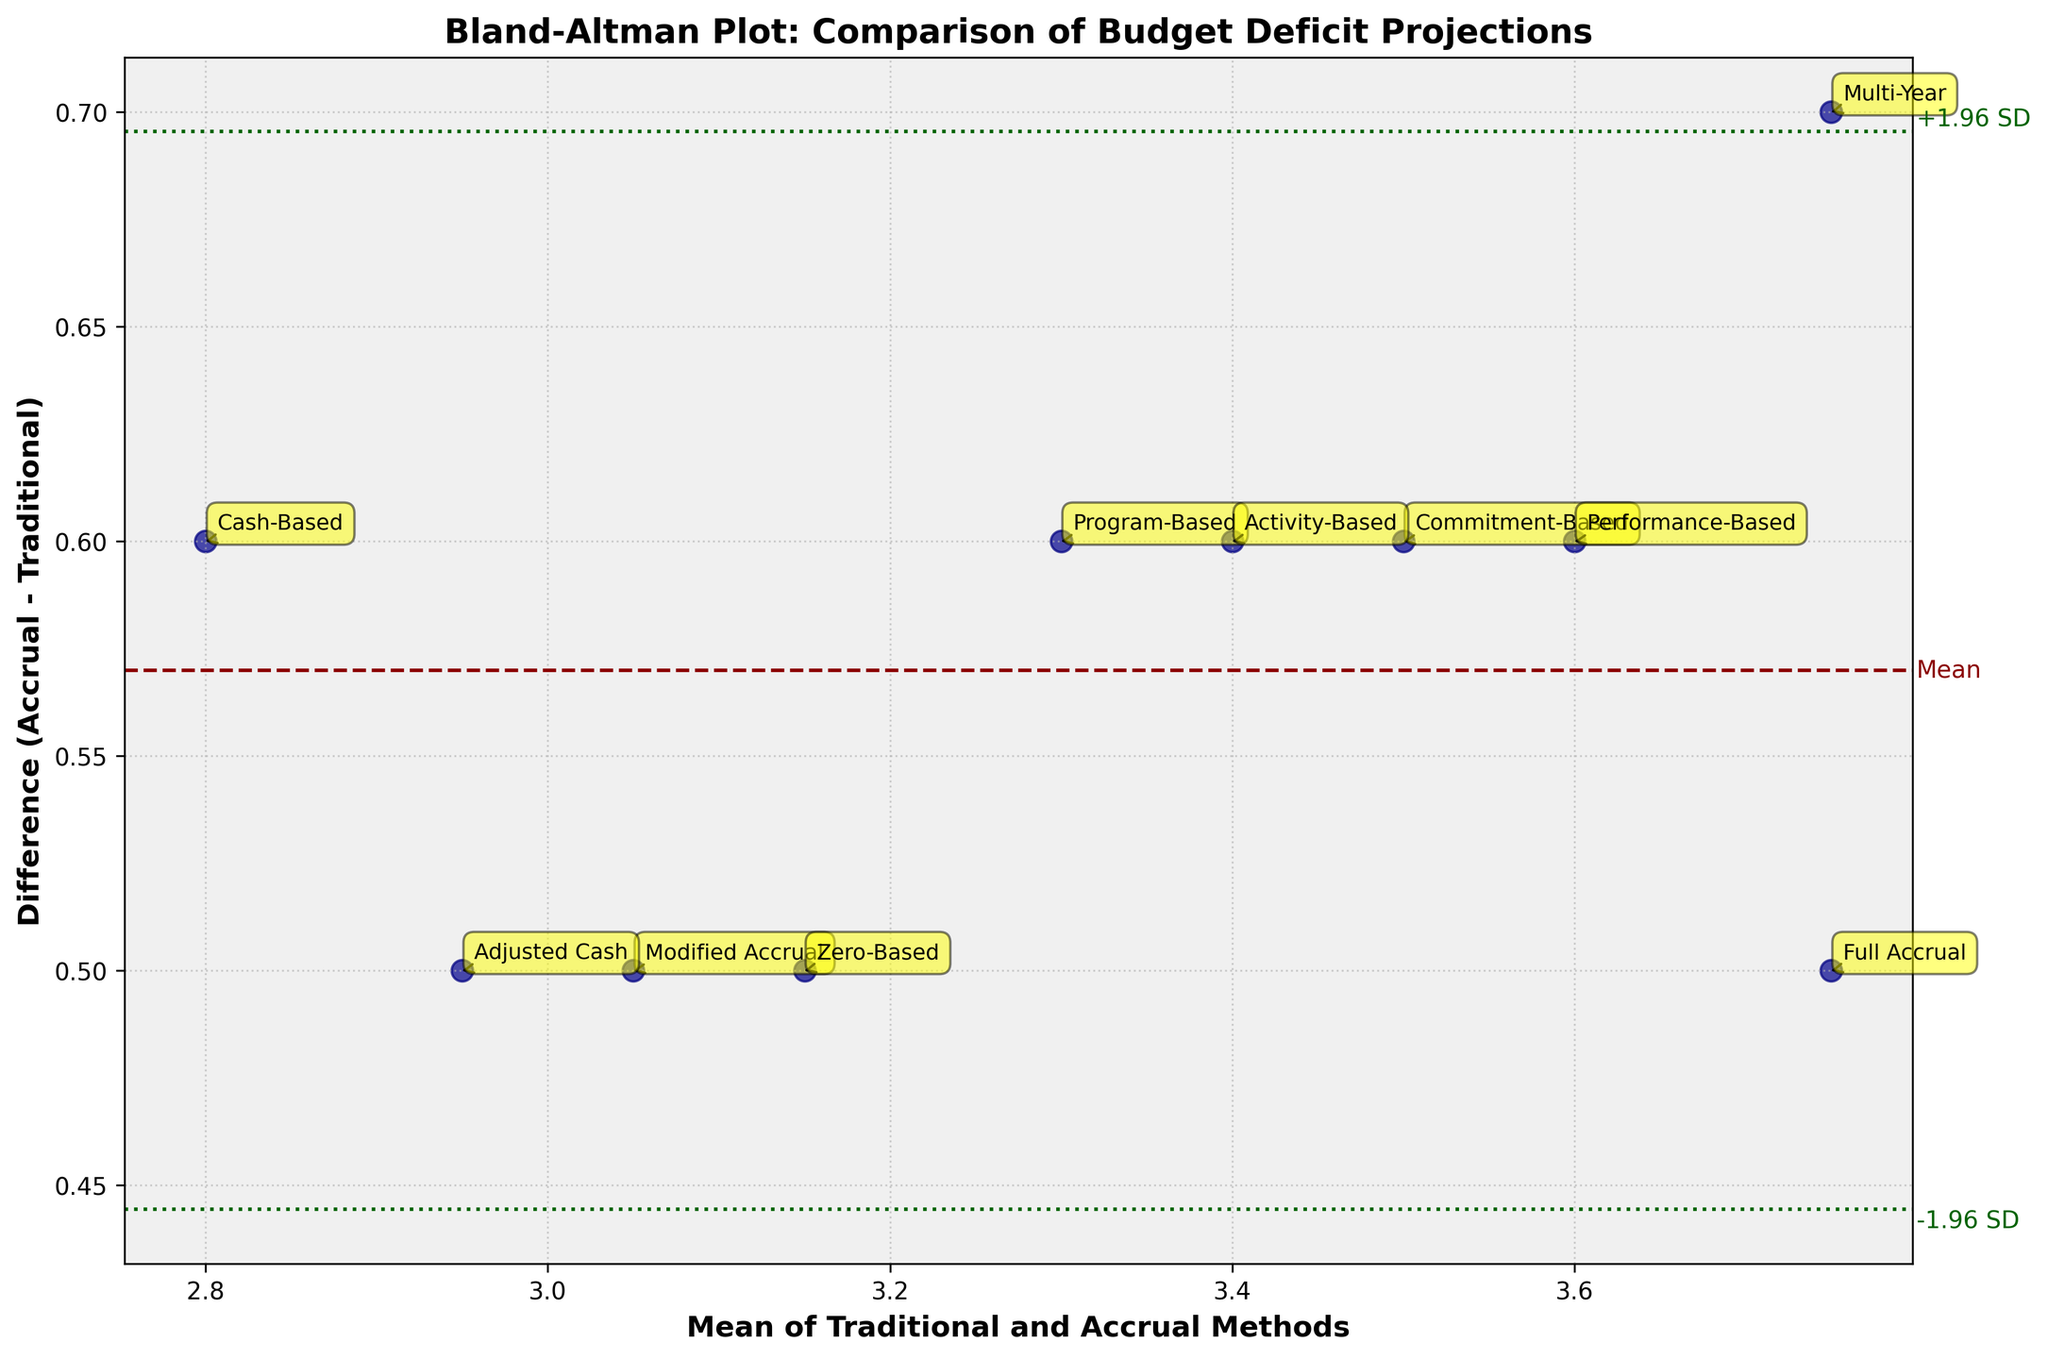What is the title of the plot? The title appears at the top of the figure and describes what the plot is about.
Answer: Bland-Altman Plot: Comparison of Budget Deficit Projections How many methods are compared in the plot? The plot includes several labeled points, with each label representing a method. Count these labels.
Answer: 10 What does the y-axis represent? Observing the label on the y-axis helps in identifying what data it conveys.
Answer: Difference (Accrual - Traditional) Which method shows the largest positive difference between Accrual and Traditional projections? Find the point with the highest y-axis value, then check its associated label.
Answer: Full Accrual What is the mean difference between the projections from the Accrual and Traditional methods? The horizontal dashed line represents the mean difference; check the position of this line on the y-axis.
Answer: Approximately 0.55 Which methods have a difference that falls outside the ±1.96 SD lines? Identify points that lie above or below the dotted lines which represent ±1.96 times the standard deviation from the mean difference.
Answer: Multi-Year What does the x-axis represent? The label on the x-axis provides information on the average values of methods being compared.
Answer: Mean of Traditional and Accrual Methods On the plot, which method has the lowest mean value of Traditional and Accrual projections? Locate the point farthest to the left on the x-axis and read its associated label.
Answer: Cash-Based How many methods fall within one standard deviation of the mean difference? Observe the points between the ±1.96 SD lines and count them.
Answer: 9 Based on the plot, which method has the highest mean projection value? Look for the point farthest to the right on the x-axis, as this represents the highest mean.
Answer: Multi-Year 